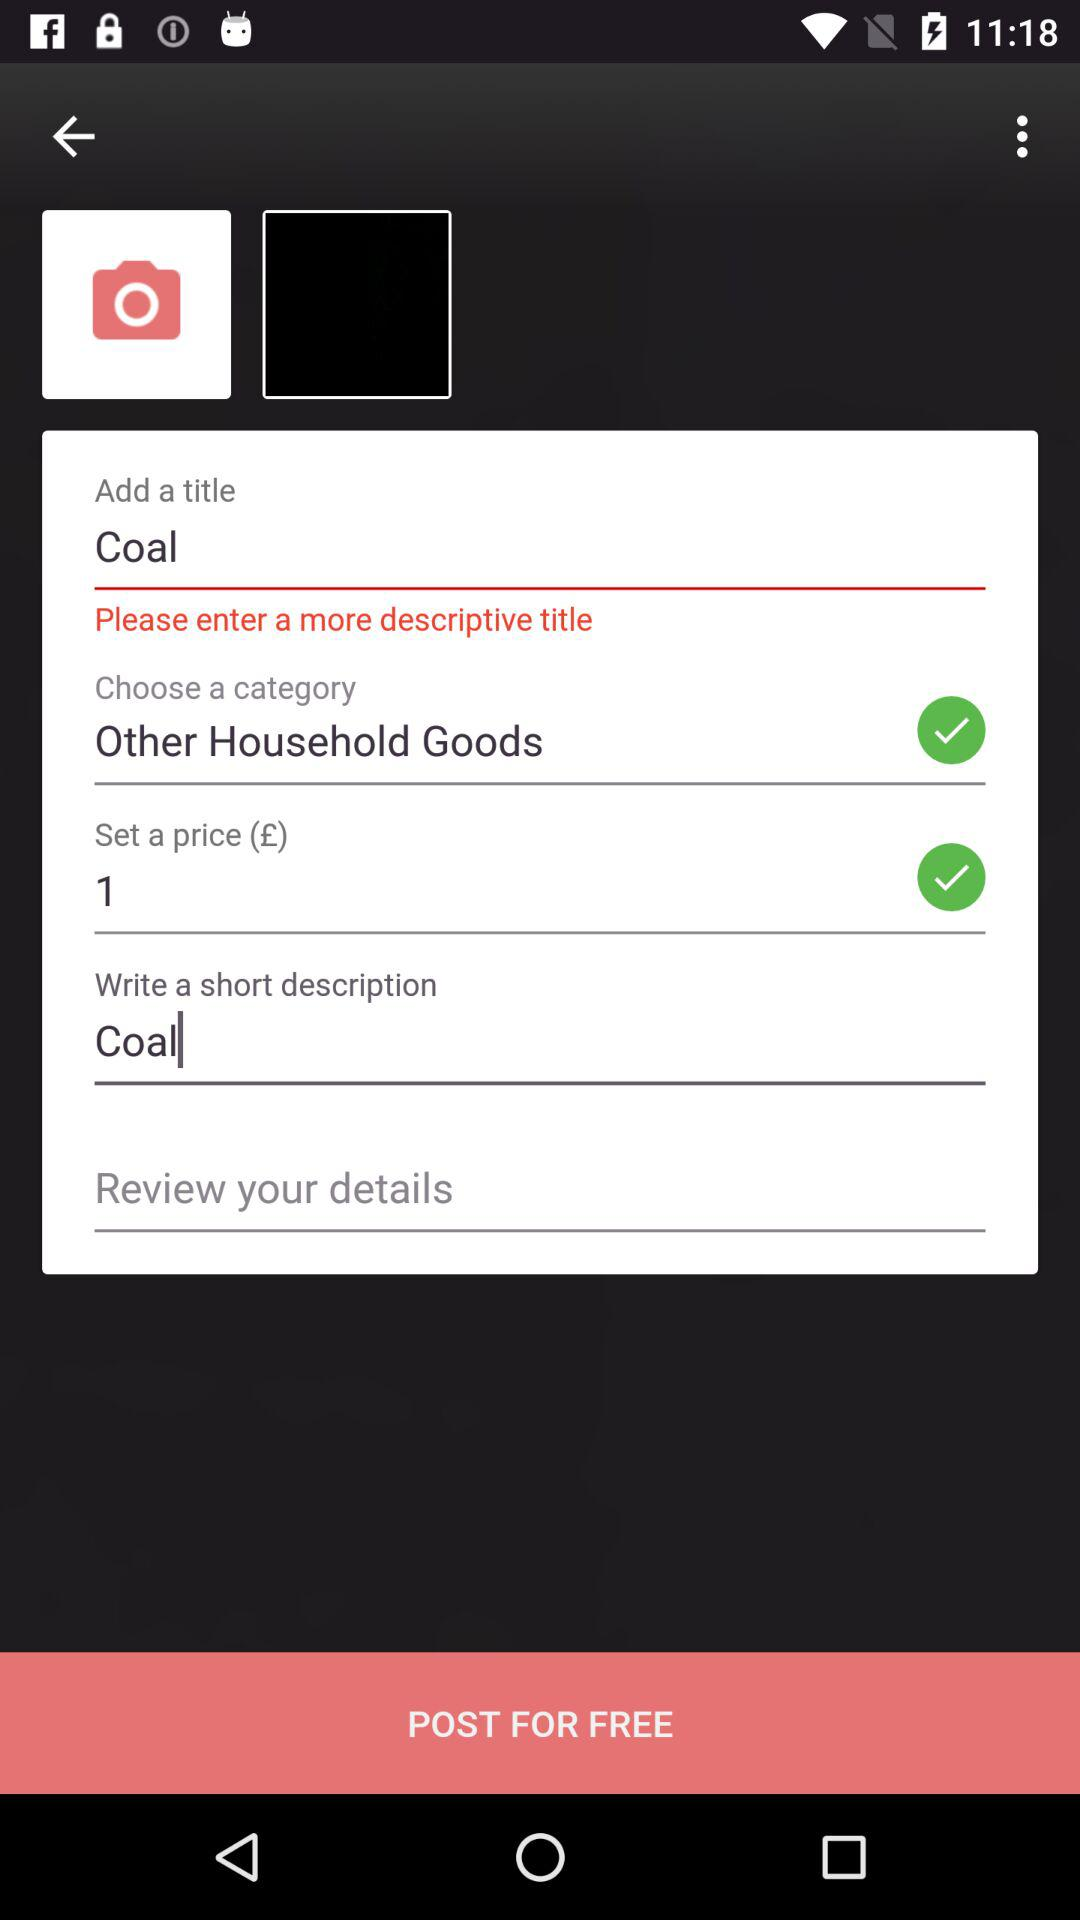What is the set price? The set price is 1. 